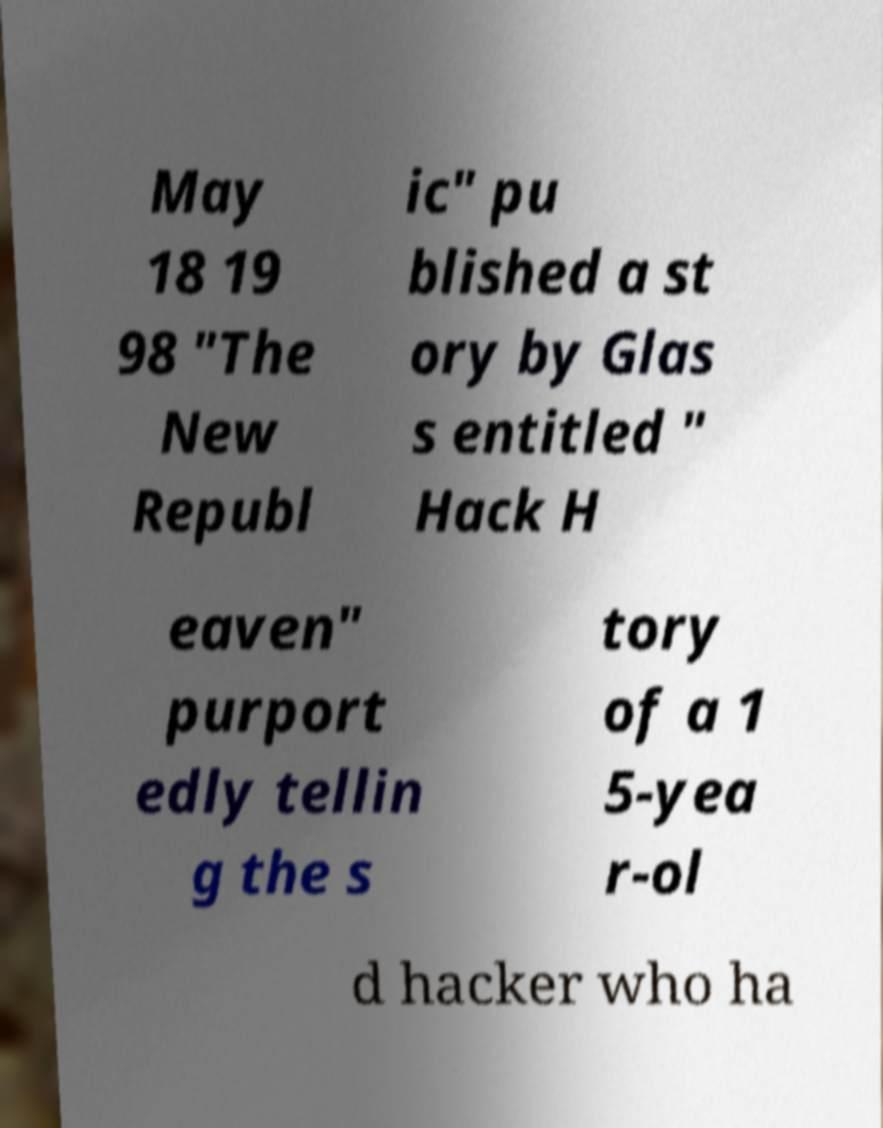Please identify and transcribe the text found in this image. May 18 19 98 "The New Republ ic" pu blished a st ory by Glas s entitled " Hack H eaven" purport edly tellin g the s tory of a 1 5-yea r-ol d hacker who ha 